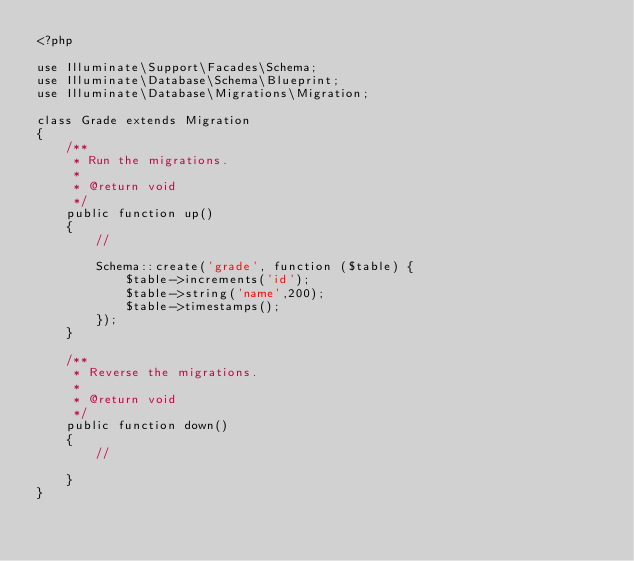Convert code to text. <code><loc_0><loc_0><loc_500><loc_500><_PHP_><?php

use Illuminate\Support\Facades\Schema;
use Illuminate\Database\Schema\Blueprint;
use Illuminate\Database\Migrations\Migration;

class Grade extends Migration
{
    /**
     * Run the migrations.
     *
     * @return void
     */
    public function up()
    {
        //

        Schema::create('grade', function ($table) {
            $table->increments('id');
            $table->string('name',200);
            $table->timestamps();
        });
    }

    /**
     * Reverse the migrations.
     *
     * @return void
     */
    public function down()
    {
        //

    }
}
</code> 